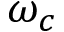<formula> <loc_0><loc_0><loc_500><loc_500>\omega _ { c }</formula> 